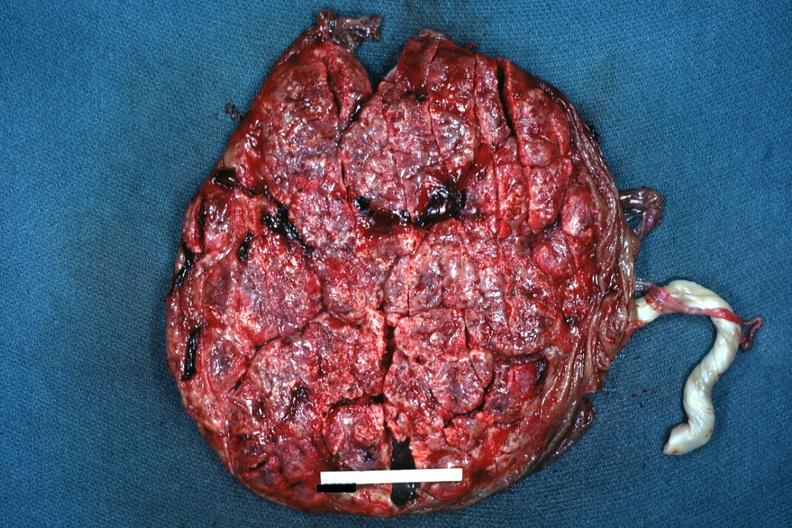what is present?
Answer the question using a single word or phrase. Female reproductive 